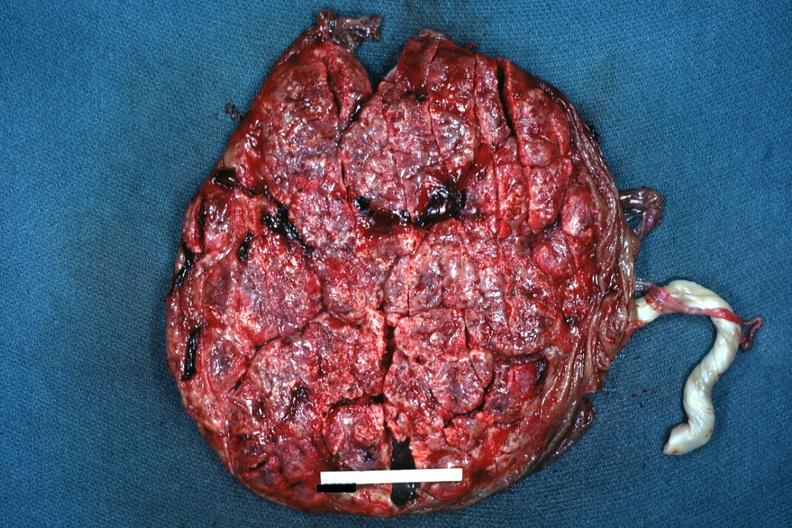what is present?
Answer the question using a single word or phrase. Female reproductive 